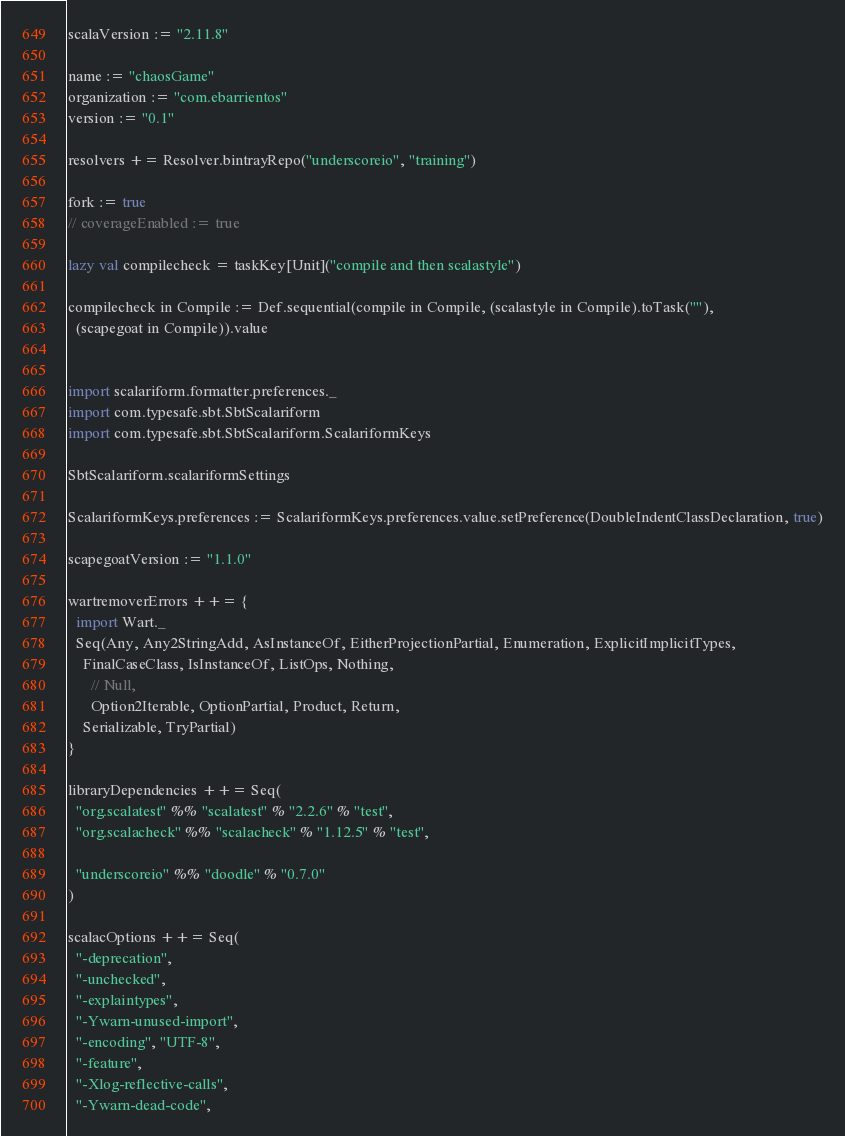<code> <loc_0><loc_0><loc_500><loc_500><_Scala_>scalaVersion := "2.11.8"

name := "chaosGame"
organization := "com.ebarrientos"
version := "0.1"

resolvers += Resolver.bintrayRepo("underscoreio", "training")

fork := true
// coverageEnabled := true

lazy val compilecheck = taskKey[Unit]("compile and then scalastyle")

compilecheck in Compile := Def.sequential(compile in Compile, (scalastyle in Compile).toTask(""),
  (scapegoat in Compile)).value


import scalariform.formatter.preferences._
import com.typesafe.sbt.SbtScalariform
import com.typesafe.sbt.SbtScalariform.ScalariformKeys

SbtScalariform.scalariformSettings

ScalariformKeys.preferences := ScalariformKeys.preferences.value.setPreference(DoubleIndentClassDeclaration, true)

scapegoatVersion := "1.1.0"

wartremoverErrors ++= {
  import Wart._
  Seq(Any, Any2StringAdd, AsInstanceOf, EitherProjectionPartial, Enumeration, ExplicitImplicitTypes,
    FinalCaseClass, IsInstanceOf, ListOps, Nothing,
      // Null,
      Option2Iterable, OptionPartial, Product, Return,
    Serializable, TryPartial)
}

libraryDependencies ++= Seq(
  "org.scalatest" %% "scalatest" % "2.2.6" % "test",
  "org.scalacheck" %% "scalacheck" % "1.12.5" % "test",

  "underscoreio" %% "doodle" % "0.7.0"
)

scalacOptions ++= Seq(
  "-deprecation",
  "-unchecked",
  "-explaintypes",
  "-Ywarn-unused-import",
  "-encoding", "UTF-8",
  "-feature",
  "-Xlog-reflective-calls",
  "-Ywarn-dead-code",</code> 